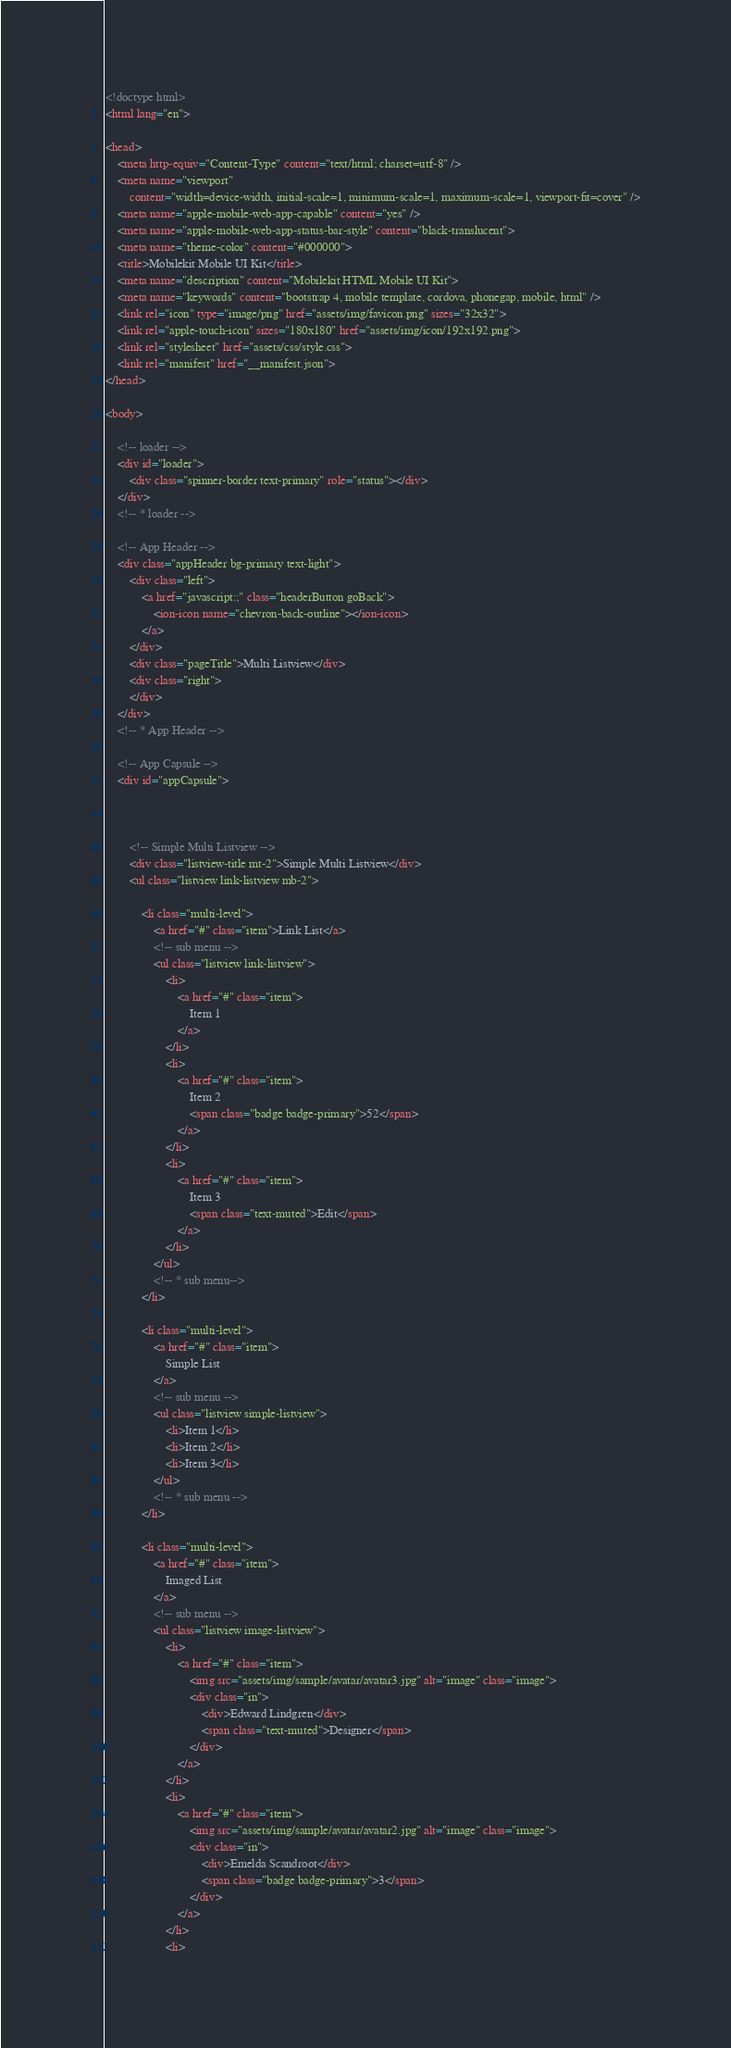Convert code to text. <code><loc_0><loc_0><loc_500><loc_500><_HTML_><!doctype html>
<html lang="en">

<head>
    <meta http-equiv="Content-Type" content="text/html; charset=utf-8" />
    <meta name="viewport"
        content="width=device-width, initial-scale=1, minimum-scale=1, maximum-scale=1, viewport-fit=cover" />
    <meta name="apple-mobile-web-app-capable" content="yes" />
    <meta name="apple-mobile-web-app-status-bar-style" content="black-translucent">
    <meta name="theme-color" content="#000000">
    <title>Mobilekit Mobile UI Kit</title>
    <meta name="description" content="Mobilekit HTML Mobile UI Kit">
    <meta name="keywords" content="bootstrap 4, mobile template, cordova, phonegap, mobile, html" />
    <link rel="icon" type="image/png" href="assets/img/favicon.png" sizes="32x32">
    <link rel="apple-touch-icon" sizes="180x180" href="assets/img/icon/192x192.png">
    <link rel="stylesheet" href="assets/css/style.css">
    <link rel="manifest" href="__manifest.json">
</head>

<body>

    <!-- loader -->
    <div id="loader">
        <div class="spinner-border text-primary" role="status"></div>
    </div>
    <!-- * loader -->

    <!-- App Header -->
    <div class="appHeader bg-primary text-light">
        <div class="left">
            <a href="javascript:;" class="headerButton goBack">
                <ion-icon name="chevron-back-outline"></ion-icon>
            </a>
        </div>
        <div class="pageTitle">Multi Listview</div>
        <div class="right">
        </div>
    </div>
    <!-- * App Header -->

    <!-- App Capsule -->
    <div id="appCapsule">



        <!-- Simple Multi Listview -->
        <div class="listview-title mt-2">Simple Multi Listview</div>
        <ul class="listview link-listview mb-2">

            <li class="multi-level">
                <a href="#" class="item">Link List</a>
                <!-- sub menu -->
                <ul class="listview link-listview">
                    <li>
                        <a href="#" class="item">
                            Item 1
                        </a>
                    </li>
                    <li>
                        <a href="#" class="item">
                            Item 2
                            <span class="badge badge-primary">52</span>
                        </a>
                    </li>
                    <li>
                        <a href="#" class="item">
                            Item 3
                            <span class="text-muted">Edit</span>
                        </a>
                    </li>
                </ul>
                <!-- * sub menu-->
            </li>

            <li class="multi-level">
                <a href="#" class="item">
                    Simple List
                </a>
                <!-- sub menu -->
                <ul class="listview simple-listview">
                    <li>Item 1</li>
                    <li>Item 2</li>
                    <li>Item 3</li>
                </ul>
                <!-- * sub menu -->
            </li>

            <li class="multi-level">
                <a href="#" class="item">
                    Imaged List
                </a>
                <!-- sub menu -->
                <ul class="listview image-listview">
                    <li>
                        <a href="#" class="item">
                            <img src="assets/img/sample/avatar/avatar3.jpg" alt="image" class="image">
                            <div class="in">
                                <div>Edward Lindgren</div>
                                <span class="text-muted">Designer</span>
                            </div>
                        </a>
                    </li>
                    <li>
                        <a href="#" class="item">
                            <img src="assets/img/sample/avatar/avatar2.jpg" alt="image" class="image">
                            <div class="in">
                                <div>Emelda Scandroot</div>
                                <span class="badge badge-primary">3</span>
                            </div>
                        </a>
                    </li>
                    <li></code> 